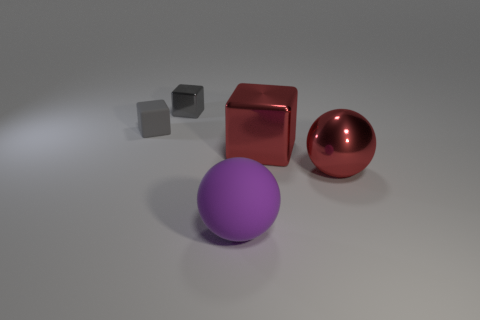Subtract all cyan cylinders. How many gray blocks are left? 2 Subtract all gray cubes. How many cubes are left? 1 Add 4 brown things. How many objects exist? 9 Subtract all green spheres. Subtract all red balls. How many objects are left? 4 Add 5 purple spheres. How many purple spheres are left? 6 Add 3 purple rubber spheres. How many purple rubber spheres exist? 4 Subtract 0 brown blocks. How many objects are left? 5 Subtract all spheres. How many objects are left? 3 Subtract all blue blocks. Subtract all brown cylinders. How many blocks are left? 3 